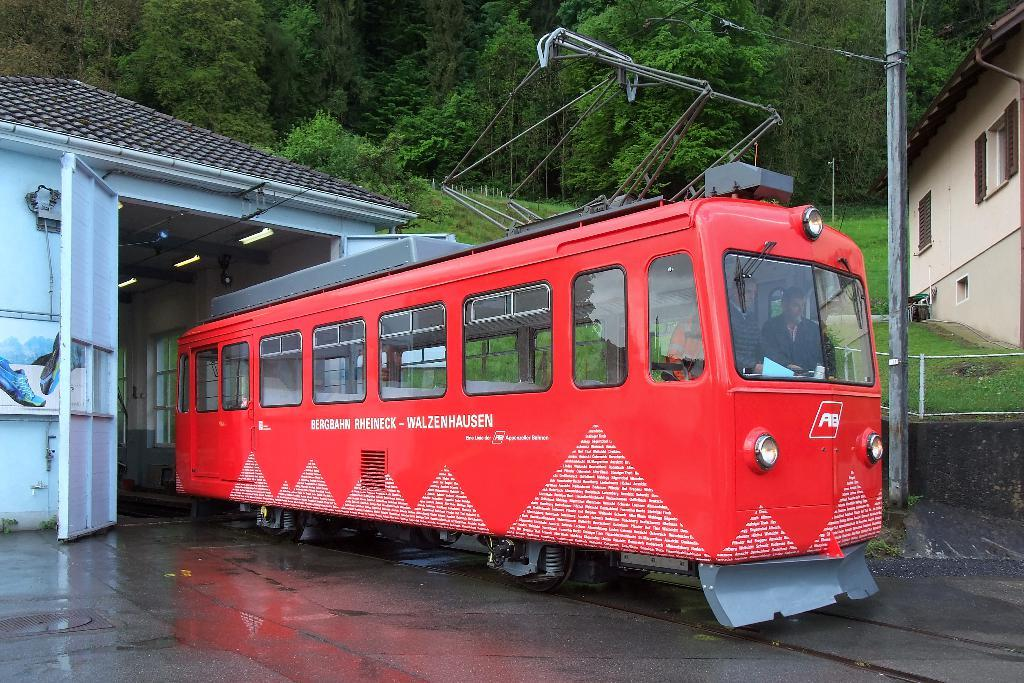What is the main subject in the center of the image? There is a bus in the center of the image. Where is the bus located? The bus is on the road. What can be seen in the background of the image? There are sheds, trees, a pole, and wires in the background of the image. What type of tooth is visible on the bus in the image? There is no tooth visible on the bus in the image. What kind of plant is growing on the pole in the background? There is no plant growing on the pole in the background; it is a pole with wires attached to it. 